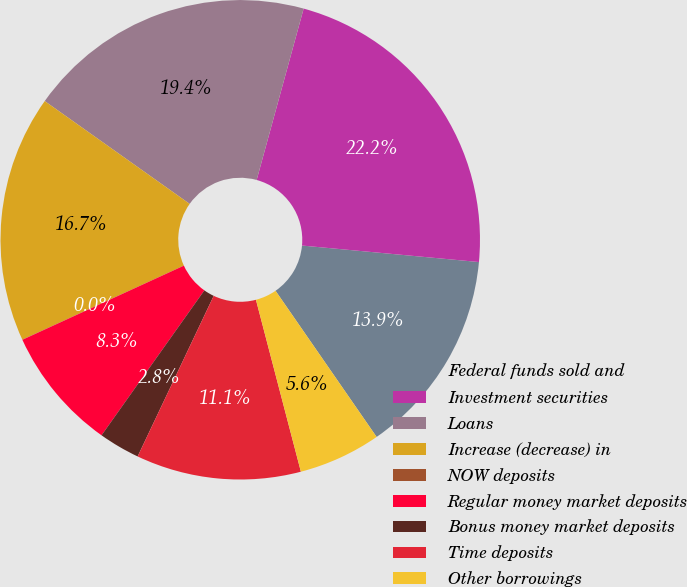Convert chart. <chart><loc_0><loc_0><loc_500><loc_500><pie_chart><fcel>Federal funds sold and<fcel>Investment securities<fcel>Loans<fcel>Increase (decrease) in<fcel>NOW deposits<fcel>Regular money market deposits<fcel>Bonus money market deposits<fcel>Time deposits<fcel>Other borrowings<nl><fcel>13.89%<fcel>22.22%<fcel>19.44%<fcel>16.66%<fcel>0.01%<fcel>8.33%<fcel>2.78%<fcel>11.11%<fcel>5.56%<nl></chart> 